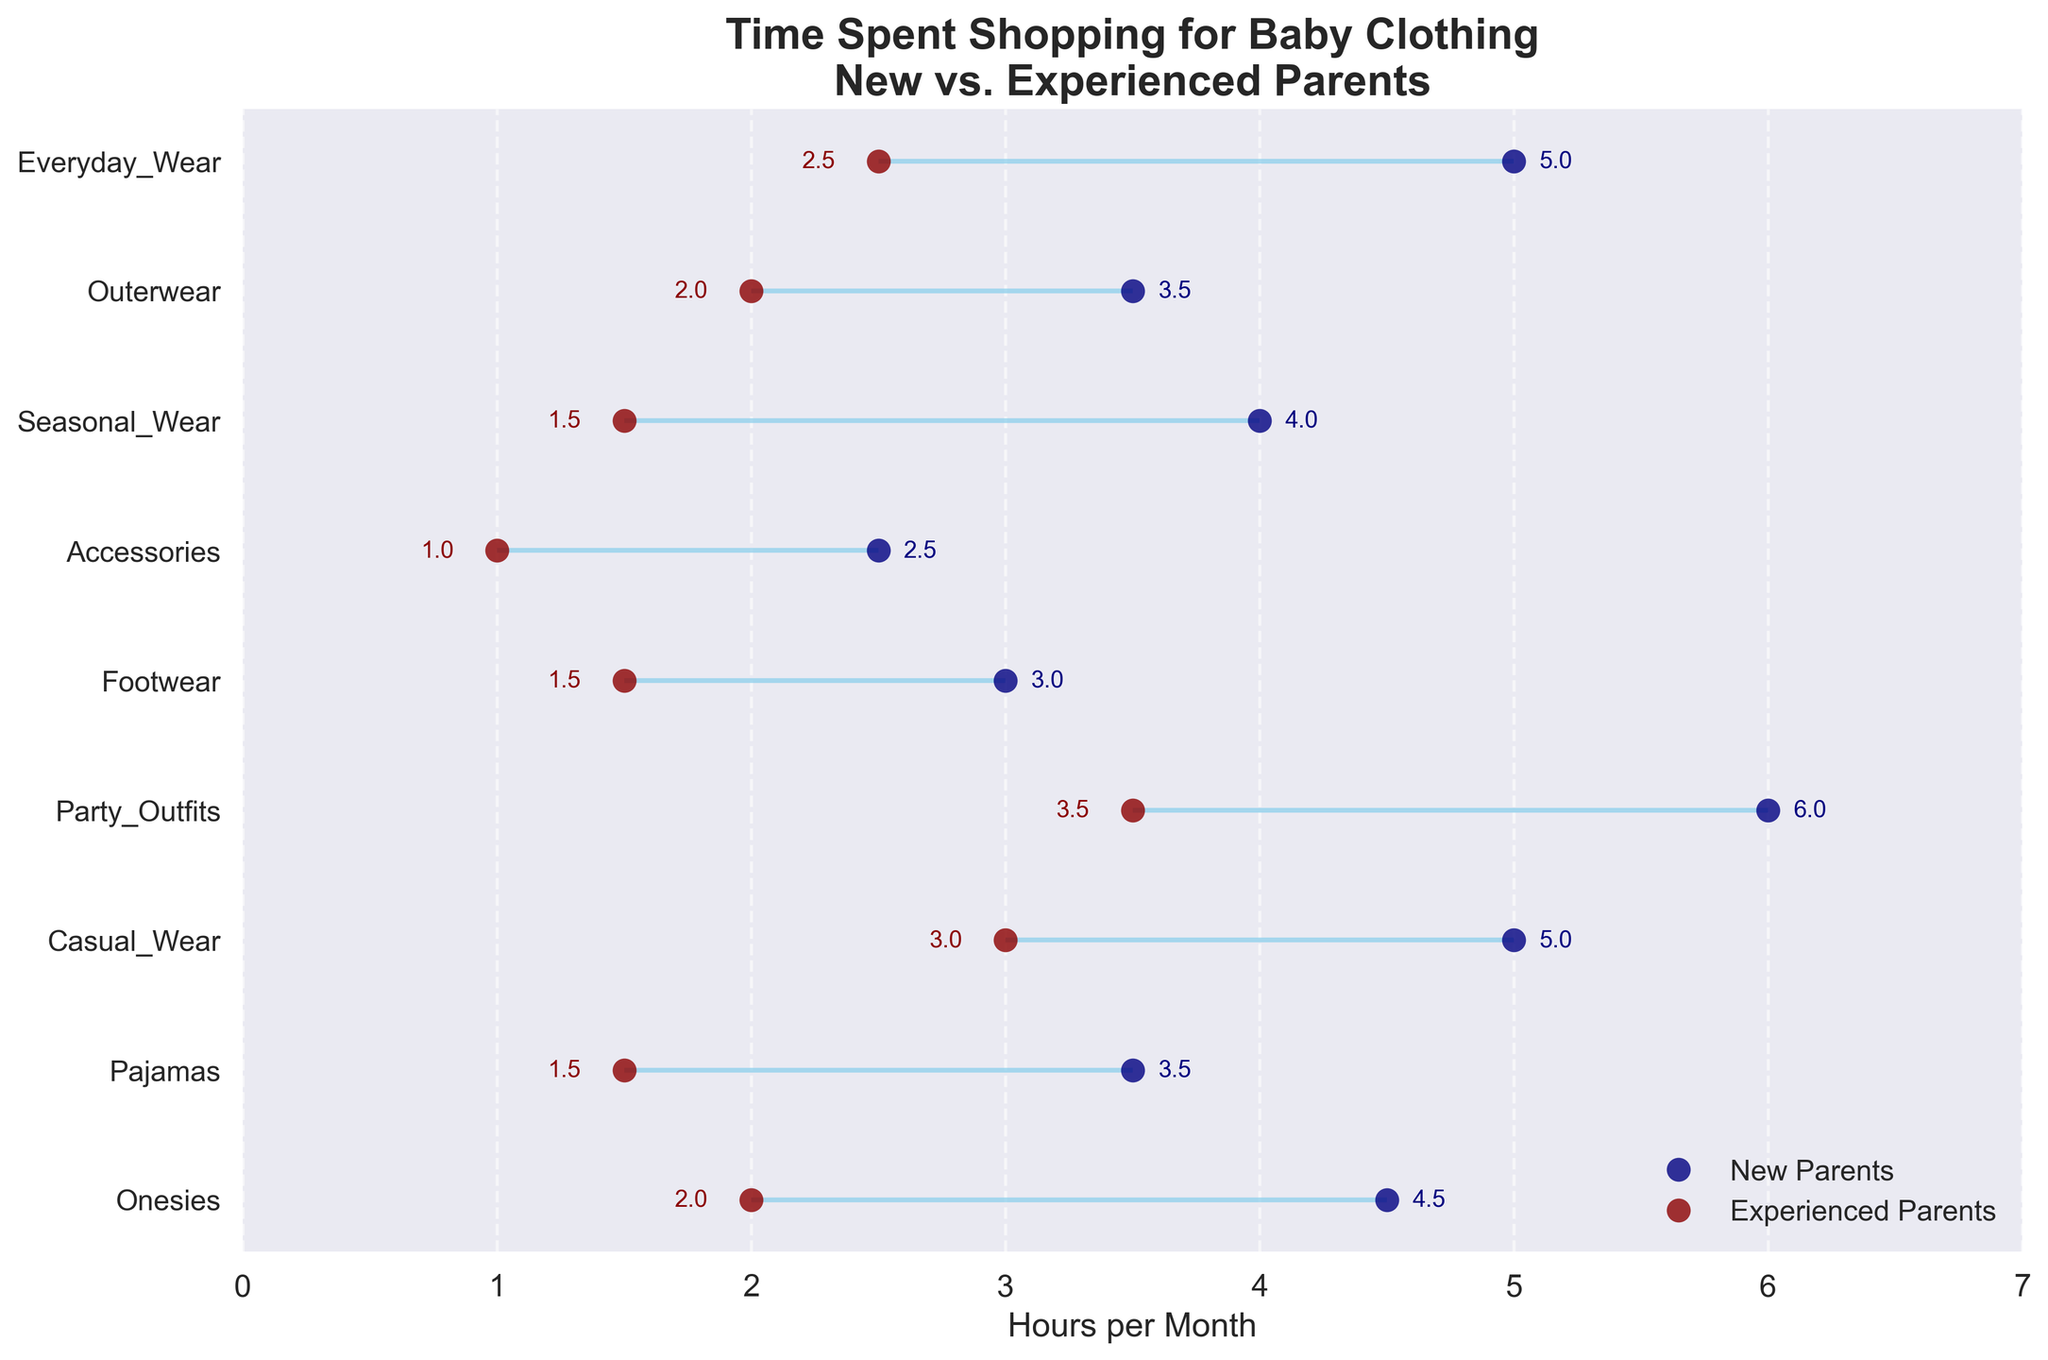What's the title of the plot? The title is located at the top of the plot, and it clearly states the main subject of the data. The plot title is "Time Spent Shopping for Baby Clothing\nNew vs. Experienced Parents".
Answer: Time Spent Shopping for Baby Clothing\nNew vs. Experienced Parents What are the colors representing new and experienced parents? The figure uses different colors to distinguish between new and experienced parents. The new parents are represented by navy blue dots, while the experienced parents are represented by dark red dots.
Answer: navy blue and dark red Which category takes the most time for new parents to shop? By examining the horizontal positions of the navy blue dots, we can see which category has the highest value. Party Outfits (H&M Kids) at 6.0 hours per month is the highest.
Answer: Party Outfits (H&M Kids) What is the difference in time spent on shopping for pajamas between new and experienced parents? To find this, subtract the number of hours for experienced parents from the number of hours for new parents: 3.5 - 1.5.
Answer: 2.0 hours Which category has the smallest difference in time spent shopping between new and experienced parents? To determine this, we look for the smallest range between the two dots. Footwear (Nike) has a difference of 1.5 hours (3.0 - 1.5 = 1.5 hours).
Answer: Footwear (Nike) How do new and experienced parents compare in terms of time spent on shopping for everyday wear? Examining the Everyday Wear category, new parents spend 5.0 hours, while experienced parents spend 2.5 hours per month. 5.0 is greater than 2.5.
Answer: New parents spend more time What is the average time spent by new parents on all categories? Sum the hours for new parents in all categories and divide by the number of categories (9): (4.5 + 3.5 + 5.0 + 6.0 + 3.0 + 2.5 + 4.0 + 3.5 + 5.0) / 9 = 4.22.
Answer: 4.22 hours per month Which category shows the largest difference between new and experienced parents? The largest gap between the navy blue and dark red dots is for Party Outfits (H&M Kids), which is 6.0 - 3.5 = 2.5 hours.
Answer: Party Outfits (H&M Kids) Are there any categories where the time spent by new and experienced parents is the same? We need to check if there are any categories where the dots overlap completely, but in this plot, none of the categories overlap, so no category has the same time spent for both groups.
Answer: No What's the total time spent on shopping for outerwear combined by both new and experienced parents? Add the time spent by new and experienced parents for the Outerwear category: 3.5 + 2.0 = 5.5 hours.
Answer: 5.5 hours 